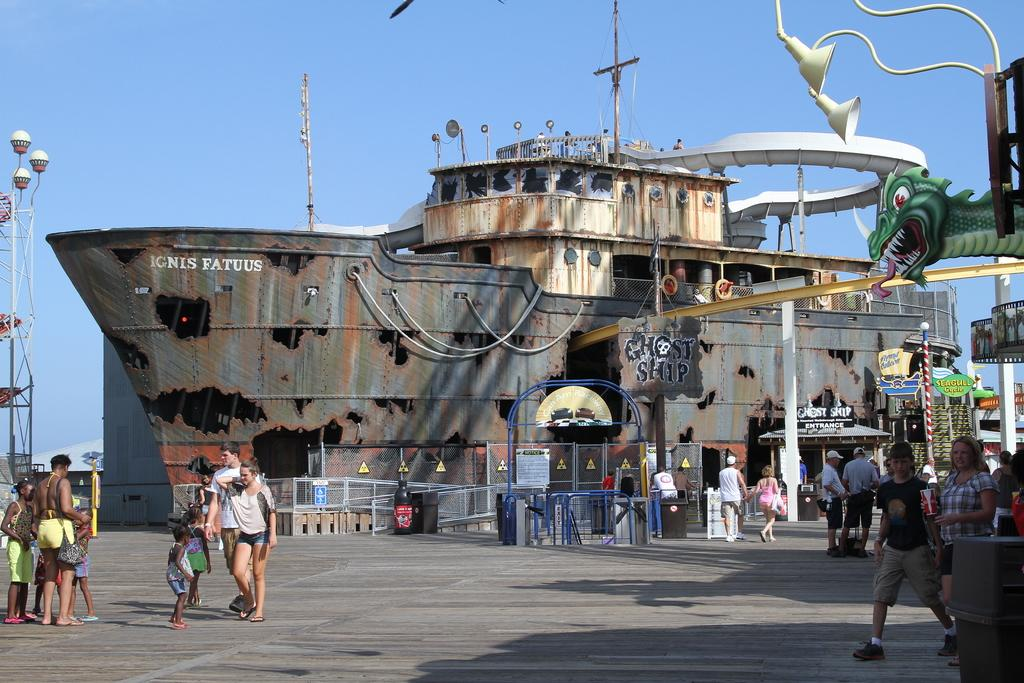What is happening on the road in the image? There is a crowd on the road in the image. What type of vehicle can be seen in the image? There is a metal boat in the image. What lighting is present in the image? Street lights are visible in the image. What type of barrier is present in the image? There is a fence in the image. What can be seen above the crowd and the boat? The sky is visible in the image. How many people are watching the boat in the image? There is no indication in the image that people are watching the boat; they are simply on the road. What is the size of the crowd in the image? The size of the crowd cannot be determined from the image alone, as there is no reference point for comparison. 